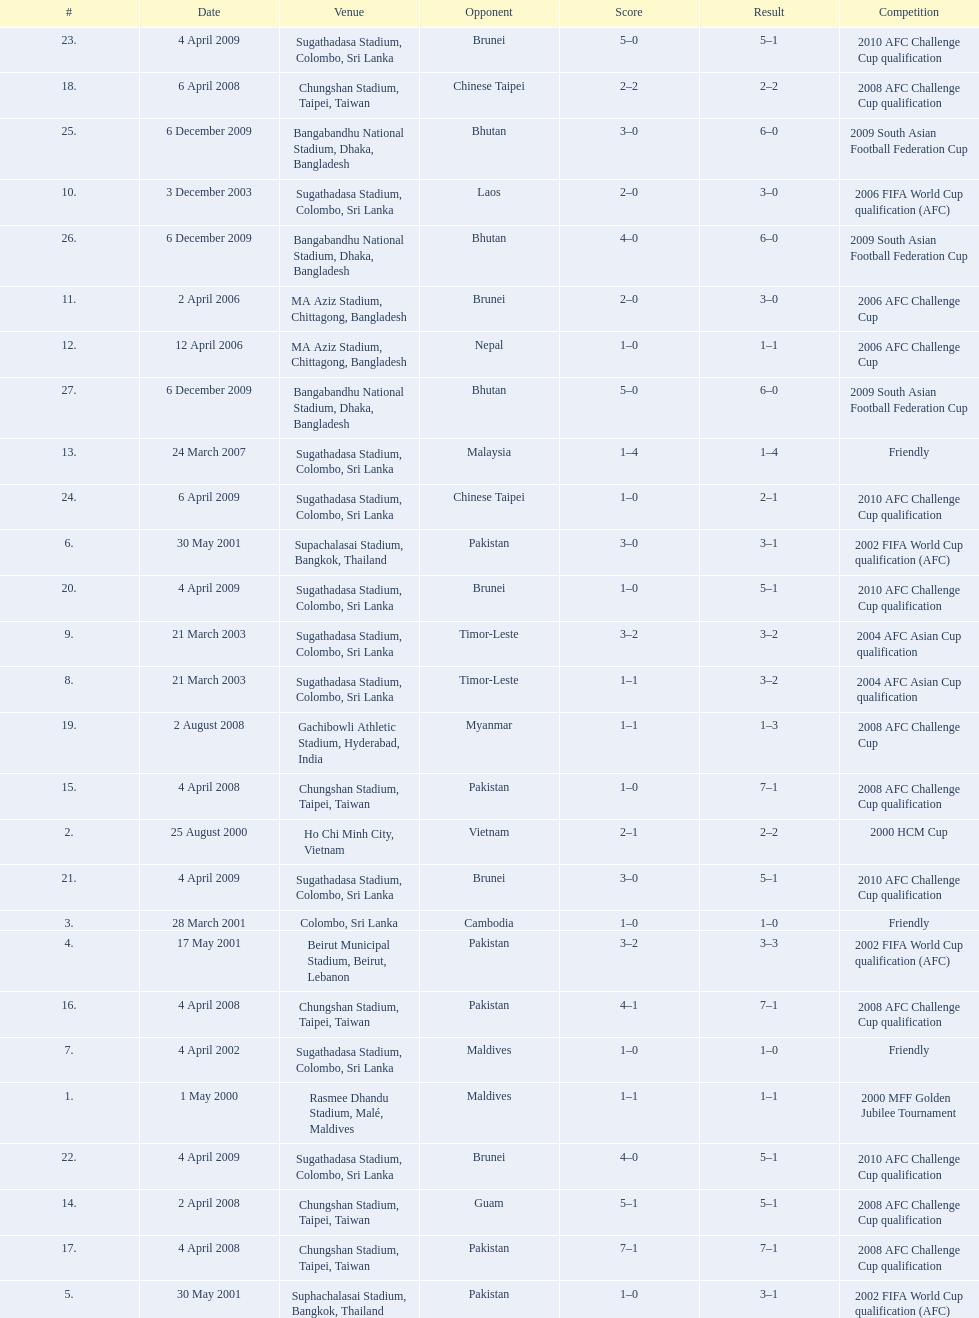How many venues are in the table? 27. Which one is the top listed? Rasmee Dhandu Stadium, Malé, Maldives. 